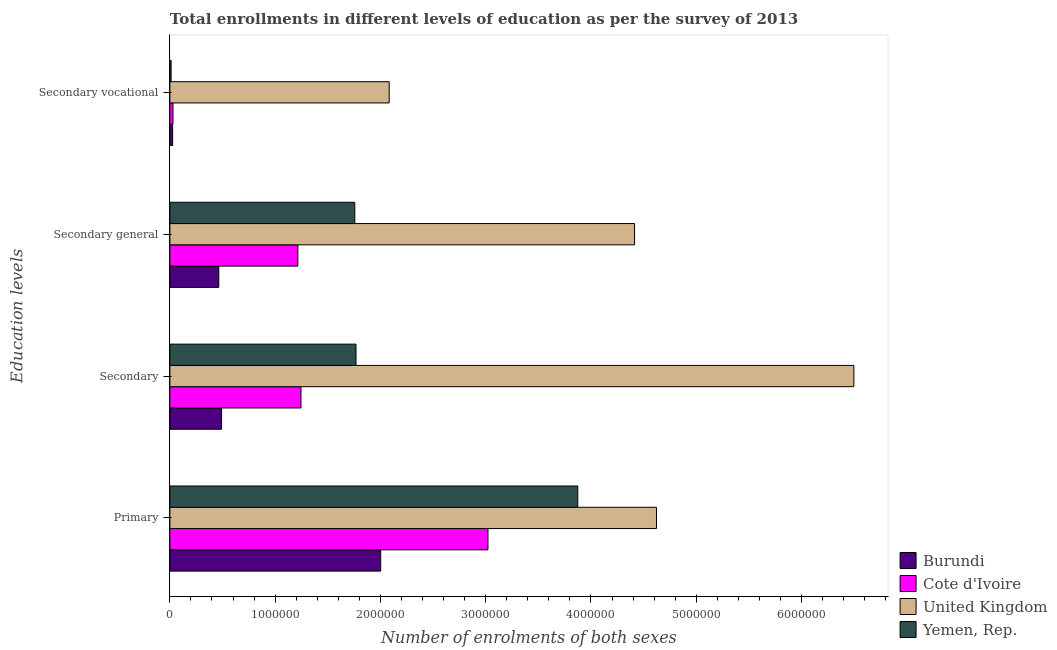How many different coloured bars are there?
Keep it short and to the point. 4. How many groups of bars are there?
Give a very brief answer. 4. Are the number of bars per tick equal to the number of legend labels?
Your answer should be very brief. Yes. Are the number of bars on each tick of the Y-axis equal?
Offer a very short reply. Yes. How many bars are there on the 4th tick from the top?
Offer a terse response. 4. How many bars are there on the 2nd tick from the bottom?
Your response must be concise. 4. What is the label of the 2nd group of bars from the top?
Make the answer very short. Secondary general. What is the number of enrolments in secondary vocational education in Yemen, Rep.?
Ensure brevity in your answer.  1.17e+04. Across all countries, what is the maximum number of enrolments in secondary general education?
Make the answer very short. 4.41e+06. Across all countries, what is the minimum number of enrolments in secondary education?
Your response must be concise. 4.91e+05. In which country was the number of enrolments in secondary vocational education maximum?
Keep it short and to the point. United Kingdom. In which country was the number of enrolments in secondary education minimum?
Your response must be concise. Burundi. What is the total number of enrolments in primary education in the graph?
Your answer should be very brief. 1.35e+07. What is the difference between the number of enrolments in secondary general education in Cote d'Ivoire and that in Yemen, Rep.?
Provide a succinct answer. -5.41e+05. What is the difference between the number of enrolments in secondary general education in Yemen, Rep. and the number of enrolments in secondary education in United Kingdom?
Offer a very short reply. -4.74e+06. What is the average number of enrolments in secondary general education per country?
Provide a succinct answer. 1.96e+06. What is the difference between the number of enrolments in primary education and number of enrolments in secondary vocational education in United Kingdom?
Ensure brevity in your answer.  2.54e+06. In how many countries, is the number of enrolments in secondary general education greater than 200000 ?
Your answer should be very brief. 4. What is the ratio of the number of enrolments in secondary education in Yemen, Rep. to that in Cote d'Ivoire?
Your response must be concise. 1.42. Is the difference between the number of enrolments in secondary general education in Cote d'Ivoire and United Kingdom greater than the difference between the number of enrolments in secondary education in Cote d'Ivoire and United Kingdom?
Ensure brevity in your answer.  Yes. What is the difference between the highest and the second highest number of enrolments in secondary education?
Your response must be concise. 4.73e+06. What is the difference between the highest and the lowest number of enrolments in secondary general education?
Your response must be concise. 3.95e+06. In how many countries, is the number of enrolments in secondary education greater than the average number of enrolments in secondary education taken over all countries?
Your answer should be compact. 1. Is the sum of the number of enrolments in secondary education in Yemen, Rep. and United Kingdom greater than the maximum number of enrolments in primary education across all countries?
Offer a terse response. Yes. Is it the case that in every country, the sum of the number of enrolments in secondary education and number of enrolments in primary education is greater than the sum of number of enrolments in secondary general education and number of enrolments in secondary vocational education?
Your answer should be compact. No. What does the 4th bar from the top in Secondary represents?
Provide a short and direct response. Burundi. What does the 4th bar from the bottom in Secondary vocational represents?
Your response must be concise. Yemen, Rep. How many bars are there?
Offer a very short reply. 16. What is the difference between two consecutive major ticks on the X-axis?
Offer a very short reply. 1.00e+06. Are the values on the major ticks of X-axis written in scientific E-notation?
Keep it short and to the point. No. Does the graph contain any zero values?
Offer a terse response. No. Does the graph contain grids?
Keep it short and to the point. No. How are the legend labels stacked?
Your answer should be compact. Vertical. What is the title of the graph?
Ensure brevity in your answer.  Total enrollments in different levels of education as per the survey of 2013. What is the label or title of the X-axis?
Give a very brief answer. Number of enrolments of both sexes. What is the label or title of the Y-axis?
Offer a very short reply. Education levels. What is the Number of enrolments of both sexes in Burundi in Primary?
Your answer should be compact. 2.00e+06. What is the Number of enrolments of both sexes in Cote d'Ivoire in Primary?
Give a very brief answer. 3.02e+06. What is the Number of enrolments of both sexes in United Kingdom in Primary?
Provide a short and direct response. 4.62e+06. What is the Number of enrolments of both sexes in Yemen, Rep. in Primary?
Offer a very short reply. 3.87e+06. What is the Number of enrolments of both sexes in Burundi in Secondary?
Provide a short and direct response. 4.91e+05. What is the Number of enrolments of both sexes in Cote d'Ivoire in Secondary?
Offer a very short reply. 1.25e+06. What is the Number of enrolments of both sexes of United Kingdom in Secondary?
Your answer should be compact. 6.50e+06. What is the Number of enrolments of both sexes in Yemen, Rep. in Secondary?
Offer a very short reply. 1.77e+06. What is the Number of enrolments of both sexes in Burundi in Secondary general?
Make the answer very short. 4.65e+05. What is the Number of enrolments of both sexes of Cote d'Ivoire in Secondary general?
Offer a very short reply. 1.22e+06. What is the Number of enrolments of both sexes of United Kingdom in Secondary general?
Your answer should be very brief. 4.41e+06. What is the Number of enrolments of both sexes in Yemen, Rep. in Secondary general?
Offer a very short reply. 1.76e+06. What is the Number of enrolments of both sexes of Burundi in Secondary vocational?
Your response must be concise. 2.61e+04. What is the Number of enrolments of both sexes in Cote d'Ivoire in Secondary vocational?
Ensure brevity in your answer.  2.96e+04. What is the Number of enrolments of both sexes in United Kingdom in Secondary vocational?
Ensure brevity in your answer.  2.08e+06. What is the Number of enrolments of both sexes of Yemen, Rep. in Secondary vocational?
Ensure brevity in your answer.  1.17e+04. Across all Education levels, what is the maximum Number of enrolments of both sexes in Burundi?
Provide a short and direct response. 2.00e+06. Across all Education levels, what is the maximum Number of enrolments of both sexes in Cote d'Ivoire?
Ensure brevity in your answer.  3.02e+06. Across all Education levels, what is the maximum Number of enrolments of both sexes in United Kingdom?
Your response must be concise. 6.50e+06. Across all Education levels, what is the maximum Number of enrolments of both sexes of Yemen, Rep.?
Ensure brevity in your answer.  3.87e+06. Across all Education levels, what is the minimum Number of enrolments of both sexes in Burundi?
Offer a terse response. 2.61e+04. Across all Education levels, what is the minimum Number of enrolments of both sexes in Cote d'Ivoire?
Provide a short and direct response. 2.96e+04. Across all Education levels, what is the minimum Number of enrolments of both sexes of United Kingdom?
Make the answer very short. 2.08e+06. Across all Education levels, what is the minimum Number of enrolments of both sexes of Yemen, Rep.?
Ensure brevity in your answer.  1.17e+04. What is the total Number of enrolments of both sexes of Burundi in the graph?
Ensure brevity in your answer.  2.98e+06. What is the total Number of enrolments of both sexes of Cote d'Ivoire in the graph?
Provide a short and direct response. 5.51e+06. What is the total Number of enrolments of both sexes in United Kingdom in the graph?
Your answer should be very brief. 1.76e+07. What is the total Number of enrolments of both sexes of Yemen, Rep. in the graph?
Your answer should be compact. 7.41e+06. What is the difference between the Number of enrolments of both sexes in Burundi in Primary and that in Secondary?
Offer a terse response. 1.51e+06. What is the difference between the Number of enrolments of both sexes of Cote d'Ivoire in Primary and that in Secondary?
Your answer should be compact. 1.78e+06. What is the difference between the Number of enrolments of both sexes in United Kingdom in Primary and that in Secondary?
Your response must be concise. -1.87e+06. What is the difference between the Number of enrolments of both sexes of Yemen, Rep. in Primary and that in Secondary?
Keep it short and to the point. 2.11e+06. What is the difference between the Number of enrolments of both sexes in Burundi in Primary and that in Secondary general?
Give a very brief answer. 1.54e+06. What is the difference between the Number of enrolments of both sexes in Cote d'Ivoire in Primary and that in Secondary general?
Your response must be concise. 1.81e+06. What is the difference between the Number of enrolments of both sexes of United Kingdom in Primary and that in Secondary general?
Offer a very short reply. 2.08e+05. What is the difference between the Number of enrolments of both sexes in Yemen, Rep. in Primary and that in Secondary general?
Keep it short and to the point. 2.12e+06. What is the difference between the Number of enrolments of both sexes in Burundi in Primary and that in Secondary vocational?
Offer a terse response. 1.98e+06. What is the difference between the Number of enrolments of both sexes of Cote d'Ivoire in Primary and that in Secondary vocational?
Keep it short and to the point. 2.99e+06. What is the difference between the Number of enrolments of both sexes of United Kingdom in Primary and that in Secondary vocational?
Your answer should be very brief. 2.54e+06. What is the difference between the Number of enrolments of both sexes in Yemen, Rep. in Primary and that in Secondary vocational?
Provide a short and direct response. 3.86e+06. What is the difference between the Number of enrolments of both sexes of Burundi in Secondary and that in Secondary general?
Your response must be concise. 2.61e+04. What is the difference between the Number of enrolments of both sexes of Cote d'Ivoire in Secondary and that in Secondary general?
Your response must be concise. 2.96e+04. What is the difference between the Number of enrolments of both sexes in United Kingdom in Secondary and that in Secondary general?
Provide a succinct answer. 2.08e+06. What is the difference between the Number of enrolments of both sexes of Yemen, Rep. in Secondary and that in Secondary general?
Your answer should be compact. 1.17e+04. What is the difference between the Number of enrolments of both sexes in Burundi in Secondary and that in Secondary vocational?
Make the answer very short. 4.65e+05. What is the difference between the Number of enrolments of both sexes in Cote d'Ivoire in Secondary and that in Secondary vocational?
Provide a succinct answer. 1.22e+06. What is the difference between the Number of enrolments of both sexes in United Kingdom in Secondary and that in Secondary vocational?
Offer a very short reply. 4.41e+06. What is the difference between the Number of enrolments of both sexes in Yemen, Rep. in Secondary and that in Secondary vocational?
Your answer should be compact. 1.76e+06. What is the difference between the Number of enrolments of both sexes in Burundi in Secondary general and that in Secondary vocational?
Offer a very short reply. 4.39e+05. What is the difference between the Number of enrolments of both sexes of Cote d'Ivoire in Secondary general and that in Secondary vocational?
Provide a succinct answer. 1.19e+06. What is the difference between the Number of enrolments of both sexes of United Kingdom in Secondary general and that in Secondary vocational?
Your response must be concise. 2.33e+06. What is the difference between the Number of enrolments of both sexes of Yemen, Rep. in Secondary general and that in Secondary vocational?
Your answer should be very brief. 1.74e+06. What is the difference between the Number of enrolments of both sexes of Burundi in Primary and the Number of enrolments of both sexes of Cote d'Ivoire in Secondary?
Make the answer very short. 7.57e+05. What is the difference between the Number of enrolments of both sexes in Burundi in Primary and the Number of enrolments of both sexes in United Kingdom in Secondary?
Ensure brevity in your answer.  -4.49e+06. What is the difference between the Number of enrolments of both sexes of Burundi in Primary and the Number of enrolments of both sexes of Yemen, Rep. in Secondary?
Give a very brief answer. 2.34e+05. What is the difference between the Number of enrolments of both sexes of Cote d'Ivoire in Primary and the Number of enrolments of both sexes of United Kingdom in Secondary?
Offer a very short reply. -3.48e+06. What is the difference between the Number of enrolments of both sexes of Cote d'Ivoire in Primary and the Number of enrolments of both sexes of Yemen, Rep. in Secondary?
Offer a very short reply. 1.25e+06. What is the difference between the Number of enrolments of both sexes in United Kingdom in Primary and the Number of enrolments of both sexes in Yemen, Rep. in Secondary?
Offer a very short reply. 2.85e+06. What is the difference between the Number of enrolments of both sexes in Burundi in Primary and the Number of enrolments of both sexes in Cote d'Ivoire in Secondary general?
Provide a succinct answer. 7.87e+05. What is the difference between the Number of enrolments of both sexes in Burundi in Primary and the Number of enrolments of both sexes in United Kingdom in Secondary general?
Your response must be concise. -2.41e+06. What is the difference between the Number of enrolments of both sexes of Burundi in Primary and the Number of enrolments of both sexes of Yemen, Rep. in Secondary general?
Your answer should be compact. 2.46e+05. What is the difference between the Number of enrolments of both sexes in Cote d'Ivoire in Primary and the Number of enrolments of both sexes in United Kingdom in Secondary general?
Keep it short and to the point. -1.39e+06. What is the difference between the Number of enrolments of both sexes of Cote d'Ivoire in Primary and the Number of enrolments of both sexes of Yemen, Rep. in Secondary general?
Keep it short and to the point. 1.26e+06. What is the difference between the Number of enrolments of both sexes in United Kingdom in Primary and the Number of enrolments of both sexes in Yemen, Rep. in Secondary general?
Provide a succinct answer. 2.87e+06. What is the difference between the Number of enrolments of both sexes of Burundi in Primary and the Number of enrolments of both sexes of Cote d'Ivoire in Secondary vocational?
Ensure brevity in your answer.  1.97e+06. What is the difference between the Number of enrolments of both sexes of Burundi in Primary and the Number of enrolments of both sexes of United Kingdom in Secondary vocational?
Give a very brief answer. -8.07e+04. What is the difference between the Number of enrolments of both sexes of Burundi in Primary and the Number of enrolments of both sexes of Yemen, Rep. in Secondary vocational?
Keep it short and to the point. 1.99e+06. What is the difference between the Number of enrolments of both sexes of Cote d'Ivoire in Primary and the Number of enrolments of both sexes of United Kingdom in Secondary vocational?
Your answer should be very brief. 9.38e+05. What is the difference between the Number of enrolments of both sexes in Cote d'Ivoire in Primary and the Number of enrolments of both sexes in Yemen, Rep. in Secondary vocational?
Keep it short and to the point. 3.01e+06. What is the difference between the Number of enrolments of both sexes of United Kingdom in Primary and the Number of enrolments of both sexes of Yemen, Rep. in Secondary vocational?
Your answer should be compact. 4.61e+06. What is the difference between the Number of enrolments of both sexes of Burundi in Secondary and the Number of enrolments of both sexes of Cote d'Ivoire in Secondary general?
Offer a terse response. -7.25e+05. What is the difference between the Number of enrolments of both sexes in Burundi in Secondary and the Number of enrolments of both sexes in United Kingdom in Secondary general?
Your answer should be compact. -3.92e+06. What is the difference between the Number of enrolments of both sexes of Burundi in Secondary and the Number of enrolments of both sexes of Yemen, Rep. in Secondary general?
Provide a succinct answer. -1.27e+06. What is the difference between the Number of enrolments of both sexes of Cote d'Ivoire in Secondary and the Number of enrolments of both sexes of United Kingdom in Secondary general?
Offer a very short reply. -3.17e+06. What is the difference between the Number of enrolments of both sexes of Cote d'Ivoire in Secondary and the Number of enrolments of both sexes of Yemen, Rep. in Secondary general?
Keep it short and to the point. -5.11e+05. What is the difference between the Number of enrolments of both sexes in United Kingdom in Secondary and the Number of enrolments of both sexes in Yemen, Rep. in Secondary general?
Keep it short and to the point. 4.74e+06. What is the difference between the Number of enrolments of both sexes in Burundi in Secondary and the Number of enrolments of both sexes in Cote d'Ivoire in Secondary vocational?
Provide a short and direct response. 4.61e+05. What is the difference between the Number of enrolments of both sexes of Burundi in Secondary and the Number of enrolments of both sexes of United Kingdom in Secondary vocational?
Your answer should be very brief. -1.59e+06. What is the difference between the Number of enrolments of both sexes of Burundi in Secondary and the Number of enrolments of both sexes of Yemen, Rep. in Secondary vocational?
Your response must be concise. 4.79e+05. What is the difference between the Number of enrolments of both sexes of Cote d'Ivoire in Secondary and the Number of enrolments of both sexes of United Kingdom in Secondary vocational?
Provide a short and direct response. -8.38e+05. What is the difference between the Number of enrolments of both sexes in Cote d'Ivoire in Secondary and the Number of enrolments of both sexes in Yemen, Rep. in Secondary vocational?
Make the answer very short. 1.23e+06. What is the difference between the Number of enrolments of both sexes in United Kingdom in Secondary and the Number of enrolments of both sexes in Yemen, Rep. in Secondary vocational?
Your answer should be compact. 6.49e+06. What is the difference between the Number of enrolments of both sexes in Burundi in Secondary general and the Number of enrolments of both sexes in Cote d'Ivoire in Secondary vocational?
Your answer should be very brief. 4.35e+05. What is the difference between the Number of enrolments of both sexes in Burundi in Secondary general and the Number of enrolments of both sexes in United Kingdom in Secondary vocational?
Your response must be concise. -1.62e+06. What is the difference between the Number of enrolments of both sexes of Burundi in Secondary general and the Number of enrolments of both sexes of Yemen, Rep. in Secondary vocational?
Offer a terse response. 4.53e+05. What is the difference between the Number of enrolments of both sexes in Cote d'Ivoire in Secondary general and the Number of enrolments of both sexes in United Kingdom in Secondary vocational?
Ensure brevity in your answer.  -8.67e+05. What is the difference between the Number of enrolments of both sexes of Cote d'Ivoire in Secondary general and the Number of enrolments of both sexes of Yemen, Rep. in Secondary vocational?
Keep it short and to the point. 1.20e+06. What is the difference between the Number of enrolments of both sexes in United Kingdom in Secondary general and the Number of enrolments of both sexes in Yemen, Rep. in Secondary vocational?
Your answer should be very brief. 4.40e+06. What is the average Number of enrolments of both sexes in Burundi per Education levels?
Provide a short and direct response. 7.46e+05. What is the average Number of enrolments of both sexes in Cote d'Ivoire per Education levels?
Offer a very short reply. 1.38e+06. What is the average Number of enrolments of both sexes in United Kingdom per Education levels?
Offer a terse response. 4.40e+06. What is the average Number of enrolments of both sexes of Yemen, Rep. per Education levels?
Provide a succinct answer. 1.85e+06. What is the difference between the Number of enrolments of both sexes of Burundi and Number of enrolments of both sexes of Cote d'Ivoire in Primary?
Make the answer very short. -1.02e+06. What is the difference between the Number of enrolments of both sexes in Burundi and Number of enrolments of both sexes in United Kingdom in Primary?
Your answer should be very brief. -2.62e+06. What is the difference between the Number of enrolments of both sexes of Burundi and Number of enrolments of both sexes of Yemen, Rep. in Primary?
Keep it short and to the point. -1.87e+06. What is the difference between the Number of enrolments of both sexes in Cote d'Ivoire and Number of enrolments of both sexes in United Kingdom in Primary?
Offer a terse response. -1.60e+06. What is the difference between the Number of enrolments of both sexes in Cote d'Ivoire and Number of enrolments of both sexes in Yemen, Rep. in Primary?
Provide a succinct answer. -8.53e+05. What is the difference between the Number of enrolments of both sexes in United Kingdom and Number of enrolments of both sexes in Yemen, Rep. in Primary?
Ensure brevity in your answer.  7.47e+05. What is the difference between the Number of enrolments of both sexes in Burundi and Number of enrolments of both sexes in Cote d'Ivoire in Secondary?
Make the answer very short. -7.54e+05. What is the difference between the Number of enrolments of both sexes of Burundi and Number of enrolments of both sexes of United Kingdom in Secondary?
Your answer should be very brief. -6.01e+06. What is the difference between the Number of enrolments of both sexes of Burundi and Number of enrolments of both sexes of Yemen, Rep. in Secondary?
Give a very brief answer. -1.28e+06. What is the difference between the Number of enrolments of both sexes of Cote d'Ivoire and Number of enrolments of both sexes of United Kingdom in Secondary?
Your answer should be very brief. -5.25e+06. What is the difference between the Number of enrolments of both sexes in Cote d'Ivoire and Number of enrolments of both sexes in Yemen, Rep. in Secondary?
Give a very brief answer. -5.23e+05. What is the difference between the Number of enrolments of both sexes in United Kingdom and Number of enrolments of both sexes in Yemen, Rep. in Secondary?
Your answer should be very brief. 4.73e+06. What is the difference between the Number of enrolments of both sexes in Burundi and Number of enrolments of both sexes in Cote d'Ivoire in Secondary general?
Your answer should be compact. -7.51e+05. What is the difference between the Number of enrolments of both sexes in Burundi and Number of enrolments of both sexes in United Kingdom in Secondary general?
Offer a very short reply. -3.95e+06. What is the difference between the Number of enrolments of both sexes in Burundi and Number of enrolments of both sexes in Yemen, Rep. in Secondary general?
Make the answer very short. -1.29e+06. What is the difference between the Number of enrolments of both sexes in Cote d'Ivoire and Number of enrolments of both sexes in United Kingdom in Secondary general?
Make the answer very short. -3.20e+06. What is the difference between the Number of enrolments of both sexes of Cote d'Ivoire and Number of enrolments of both sexes of Yemen, Rep. in Secondary general?
Offer a terse response. -5.41e+05. What is the difference between the Number of enrolments of both sexes in United Kingdom and Number of enrolments of both sexes in Yemen, Rep. in Secondary general?
Provide a succinct answer. 2.66e+06. What is the difference between the Number of enrolments of both sexes of Burundi and Number of enrolments of both sexes of Cote d'Ivoire in Secondary vocational?
Keep it short and to the point. -3446. What is the difference between the Number of enrolments of both sexes in Burundi and Number of enrolments of both sexes in United Kingdom in Secondary vocational?
Your answer should be compact. -2.06e+06. What is the difference between the Number of enrolments of both sexes of Burundi and Number of enrolments of both sexes of Yemen, Rep. in Secondary vocational?
Your answer should be compact. 1.45e+04. What is the difference between the Number of enrolments of both sexes in Cote d'Ivoire and Number of enrolments of both sexes in United Kingdom in Secondary vocational?
Keep it short and to the point. -2.05e+06. What is the difference between the Number of enrolments of both sexes in Cote d'Ivoire and Number of enrolments of both sexes in Yemen, Rep. in Secondary vocational?
Ensure brevity in your answer.  1.79e+04. What is the difference between the Number of enrolments of both sexes in United Kingdom and Number of enrolments of both sexes in Yemen, Rep. in Secondary vocational?
Provide a succinct answer. 2.07e+06. What is the ratio of the Number of enrolments of both sexes in Burundi in Primary to that in Secondary?
Provide a short and direct response. 4.08. What is the ratio of the Number of enrolments of both sexes of Cote d'Ivoire in Primary to that in Secondary?
Provide a succinct answer. 2.43. What is the ratio of the Number of enrolments of both sexes in United Kingdom in Primary to that in Secondary?
Give a very brief answer. 0.71. What is the ratio of the Number of enrolments of both sexes in Yemen, Rep. in Primary to that in Secondary?
Your answer should be very brief. 2.19. What is the ratio of the Number of enrolments of both sexes of Burundi in Primary to that in Secondary general?
Provide a succinct answer. 4.31. What is the ratio of the Number of enrolments of both sexes of Cote d'Ivoire in Primary to that in Secondary general?
Your answer should be compact. 2.49. What is the ratio of the Number of enrolments of both sexes in United Kingdom in Primary to that in Secondary general?
Your answer should be compact. 1.05. What is the ratio of the Number of enrolments of both sexes in Yemen, Rep. in Primary to that in Secondary general?
Your response must be concise. 2.21. What is the ratio of the Number of enrolments of both sexes of Burundi in Primary to that in Secondary vocational?
Offer a very short reply. 76.58. What is the ratio of the Number of enrolments of both sexes in Cote d'Ivoire in Primary to that in Secondary vocational?
Provide a succinct answer. 102.09. What is the ratio of the Number of enrolments of both sexes of United Kingdom in Primary to that in Secondary vocational?
Offer a terse response. 2.22. What is the ratio of the Number of enrolments of both sexes in Yemen, Rep. in Primary to that in Secondary vocational?
Keep it short and to the point. 332.37. What is the ratio of the Number of enrolments of both sexes of Burundi in Secondary to that in Secondary general?
Your answer should be very brief. 1.06. What is the ratio of the Number of enrolments of both sexes in Cote d'Ivoire in Secondary to that in Secondary general?
Offer a terse response. 1.02. What is the ratio of the Number of enrolments of both sexes of United Kingdom in Secondary to that in Secondary general?
Keep it short and to the point. 1.47. What is the ratio of the Number of enrolments of both sexes of Yemen, Rep. in Secondary to that in Secondary general?
Your answer should be compact. 1.01. What is the ratio of the Number of enrolments of both sexes of Burundi in Secondary to that in Secondary vocational?
Your response must be concise. 18.77. What is the ratio of the Number of enrolments of both sexes of Cote d'Ivoire in Secondary to that in Secondary vocational?
Make the answer very short. 42.08. What is the ratio of the Number of enrolments of both sexes in United Kingdom in Secondary to that in Secondary vocational?
Your answer should be compact. 3.12. What is the ratio of the Number of enrolments of both sexes in Yemen, Rep. in Secondary to that in Secondary vocational?
Offer a terse response. 151.66. What is the ratio of the Number of enrolments of both sexes in Burundi in Secondary general to that in Secondary vocational?
Your answer should be very brief. 17.77. What is the ratio of the Number of enrolments of both sexes in Cote d'Ivoire in Secondary general to that in Secondary vocational?
Your response must be concise. 41.08. What is the ratio of the Number of enrolments of both sexes of United Kingdom in Secondary general to that in Secondary vocational?
Give a very brief answer. 2.12. What is the ratio of the Number of enrolments of both sexes in Yemen, Rep. in Secondary general to that in Secondary vocational?
Your answer should be very brief. 150.66. What is the difference between the highest and the second highest Number of enrolments of both sexes in Burundi?
Your response must be concise. 1.51e+06. What is the difference between the highest and the second highest Number of enrolments of both sexes of Cote d'Ivoire?
Provide a succinct answer. 1.78e+06. What is the difference between the highest and the second highest Number of enrolments of both sexes in United Kingdom?
Provide a short and direct response. 1.87e+06. What is the difference between the highest and the second highest Number of enrolments of both sexes of Yemen, Rep.?
Offer a terse response. 2.11e+06. What is the difference between the highest and the lowest Number of enrolments of both sexes of Burundi?
Offer a very short reply. 1.98e+06. What is the difference between the highest and the lowest Number of enrolments of both sexes in Cote d'Ivoire?
Offer a terse response. 2.99e+06. What is the difference between the highest and the lowest Number of enrolments of both sexes in United Kingdom?
Provide a short and direct response. 4.41e+06. What is the difference between the highest and the lowest Number of enrolments of both sexes of Yemen, Rep.?
Your answer should be compact. 3.86e+06. 